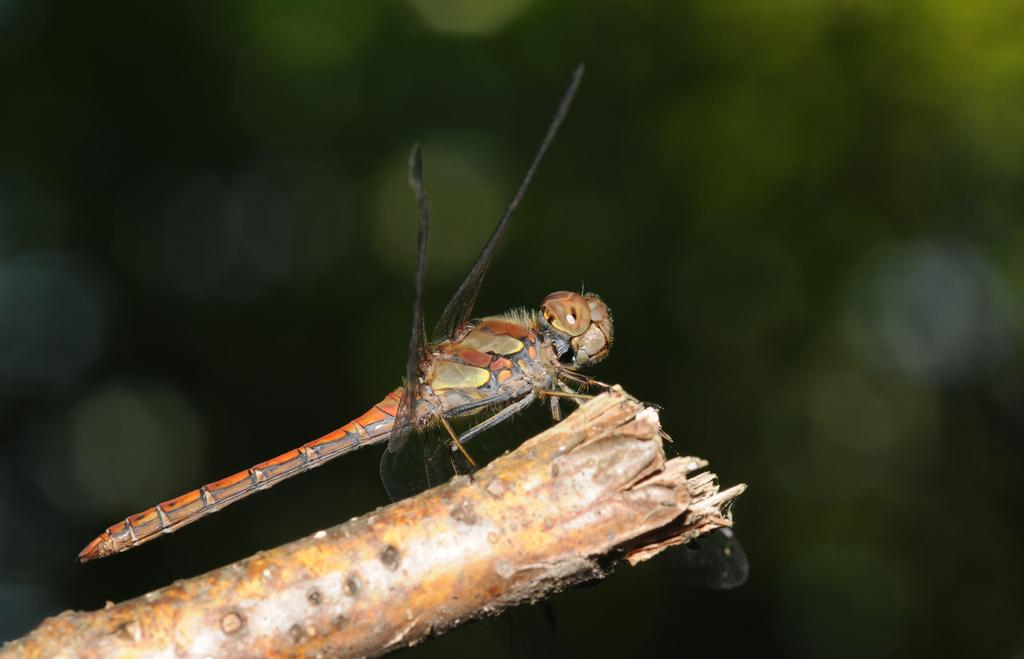What type of creature can be seen in the image? There is an insect in the image. What surface is the insect on? The insect is on wood. What type of pencil is being used by the insect in the image? There is no pencil present in the image, as it features an insect on wood. 